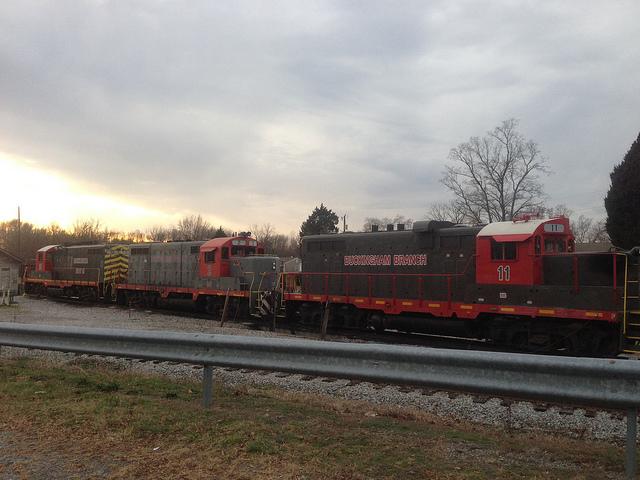What letters are on the train?
Quick response, please. Buckingham branch. Is it sunny?
Answer briefly. No. How many train carts are there?
Concise answer only. 3. What number is the train?
Quick response, please. 11. What is the person who drives the train called?
Give a very brief answer. Engineer. What types of trains are these?
Concise answer only. Cargo. How many cars are attached to the train?
Short answer required. 3. Which direction is the bottom train heading?
Write a very short answer. Right. How many poles are there?
Concise answer only. 0. What is powering the train?
Answer briefly. Coal. How cloudy is it?
Be succinct. Very. How many box cars are on the tracks?
Concise answer only. 0. 